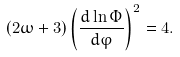Convert formula to latex. <formula><loc_0><loc_0><loc_500><loc_500>\left ( 2 \omega + 3 \right ) \left ( \frac { d \ln \Phi } { d \varphi } \right ) ^ { 2 } = 4 .</formula> 